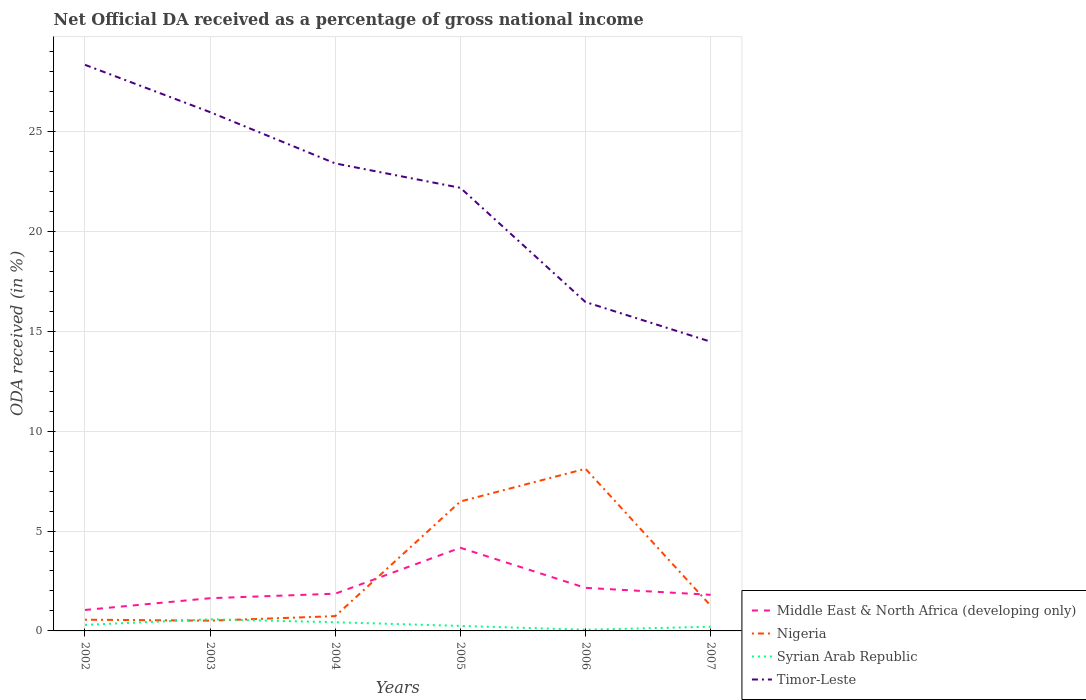Does the line corresponding to Syrian Arab Republic intersect with the line corresponding to Nigeria?
Offer a very short reply. Yes. Is the number of lines equal to the number of legend labels?
Provide a succinct answer. Yes. Across all years, what is the maximum net official DA received in Syrian Arab Republic?
Your answer should be compact. 0.06. What is the total net official DA received in Timor-Leste in the graph?
Your response must be concise. 6.94. What is the difference between the highest and the second highest net official DA received in Nigeria?
Keep it short and to the point. 7.6. Is the net official DA received in Syrian Arab Republic strictly greater than the net official DA received in Middle East & North Africa (developing only) over the years?
Make the answer very short. Yes. How many lines are there?
Offer a terse response. 4. How many years are there in the graph?
Offer a terse response. 6. What is the difference between two consecutive major ticks on the Y-axis?
Offer a very short reply. 5. Are the values on the major ticks of Y-axis written in scientific E-notation?
Provide a succinct answer. No. How many legend labels are there?
Provide a short and direct response. 4. How are the legend labels stacked?
Keep it short and to the point. Vertical. What is the title of the graph?
Your answer should be very brief. Net Official DA received as a percentage of gross national income. Does "Bahrain" appear as one of the legend labels in the graph?
Give a very brief answer. No. What is the label or title of the X-axis?
Provide a short and direct response. Years. What is the label or title of the Y-axis?
Give a very brief answer. ODA received (in %). What is the ODA received (in %) in Middle East & North Africa (developing only) in 2002?
Provide a succinct answer. 1.05. What is the ODA received (in %) of Nigeria in 2002?
Provide a succinct answer. 0.56. What is the ODA received (in %) of Syrian Arab Republic in 2002?
Keep it short and to the point. 0.3. What is the ODA received (in %) of Timor-Leste in 2002?
Provide a short and direct response. 28.34. What is the ODA received (in %) of Middle East & North Africa (developing only) in 2003?
Your answer should be compact. 1.64. What is the ODA received (in %) of Nigeria in 2003?
Keep it short and to the point. 0.51. What is the ODA received (in %) of Syrian Arab Republic in 2003?
Offer a very short reply. 0.58. What is the ODA received (in %) of Timor-Leste in 2003?
Ensure brevity in your answer.  25.97. What is the ODA received (in %) of Middle East & North Africa (developing only) in 2004?
Your response must be concise. 1.86. What is the ODA received (in %) of Nigeria in 2004?
Your answer should be compact. 0.74. What is the ODA received (in %) in Syrian Arab Republic in 2004?
Give a very brief answer. 0.43. What is the ODA received (in %) in Timor-Leste in 2004?
Keep it short and to the point. 23.4. What is the ODA received (in %) in Middle East & North Africa (developing only) in 2005?
Your answer should be compact. 4.16. What is the ODA received (in %) of Nigeria in 2005?
Make the answer very short. 6.48. What is the ODA received (in %) in Syrian Arab Republic in 2005?
Your answer should be very brief. 0.25. What is the ODA received (in %) in Timor-Leste in 2005?
Offer a very short reply. 22.18. What is the ODA received (in %) of Middle East & North Africa (developing only) in 2006?
Offer a terse response. 2.16. What is the ODA received (in %) of Nigeria in 2006?
Your answer should be compact. 8.12. What is the ODA received (in %) of Syrian Arab Republic in 2006?
Offer a very short reply. 0.06. What is the ODA received (in %) of Timor-Leste in 2006?
Make the answer very short. 16.46. What is the ODA received (in %) in Middle East & North Africa (developing only) in 2007?
Your answer should be very brief. 1.81. What is the ODA received (in %) in Nigeria in 2007?
Give a very brief answer. 1.27. What is the ODA received (in %) of Syrian Arab Republic in 2007?
Offer a very short reply. 0.21. What is the ODA received (in %) of Timor-Leste in 2007?
Provide a short and direct response. 14.48. Across all years, what is the maximum ODA received (in %) of Middle East & North Africa (developing only)?
Your answer should be compact. 4.16. Across all years, what is the maximum ODA received (in %) in Nigeria?
Provide a succinct answer. 8.12. Across all years, what is the maximum ODA received (in %) of Syrian Arab Republic?
Keep it short and to the point. 0.58. Across all years, what is the maximum ODA received (in %) of Timor-Leste?
Your answer should be very brief. 28.34. Across all years, what is the minimum ODA received (in %) in Middle East & North Africa (developing only)?
Keep it short and to the point. 1.05. Across all years, what is the minimum ODA received (in %) in Nigeria?
Provide a succinct answer. 0.51. Across all years, what is the minimum ODA received (in %) of Syrian Arab Republic?
Offer a very short reply. 0.06. Across all years, what is the minimum ODA received (in %) in Timor-Leste?
Provide a succinct answer. 14.48. What is the total ODA received (in %) in Middle East & North Africa (developing only) in the graph?
Provide a succinct answer. 12.68. What is the total ODA received (in %) of Nigeria in the graph?
Keep it short and to the point. 17.68. What is the total ODA received (in %) in Syrian Arab Republic in the graph?
Ensure brevity in your answer.  1.84. What is the total ODA received (in %) of Timor-Leste in the graph?
Provide a short and direct response. 130.83. What is the difference between the ODA received (in %) of Middle East & North Africa (developing only) in 2002 and that in 2003?
Offer a very short reply. -0.59. What is the difference between the ODA received (in %) of Nigeria in 2002 and that in 2003?
Offer a terse response. 0.05. What is the difference between the ODA received (in %) of Syrian Arab Republic in 2002 and that in 2003?
Keep it short and to the point. -0.28. What is the difference between the ODA received (in %) of Timor-Leste in 2002 and that in 2003?
Your response must be concise. 2.37. What is the difference between the ODA received (in %) in Middle East & North Africa (developing only) in 2002 and that in 2004?
Offer a very short reply. -0.81. What is the difference between the ODA received (in %) in Nigeria in 2002 and that in 2004?
Your answer should be compact. -0.18. What is the difference between the ODA received (in %) in Syrian Arab Republic in 2002 and that in 2004?
Your response must be concise. -0.13. What is the difference between the ODA received (in %) of Timor-Leste in 2002 and that in 2004?
Give a very brief answer. 4.94. What is the difference between the ODA received (in %) of Middle East & North Africa (developing only) in 2002 and that in 2005?
Your answer should be very brief. -3.11. What is the difference between the ODA received (in %) in Nigeria in 2002 and that in 2005?
Offer a very short reply. -5.92. What is the difference between the ODA received (in %) in Syrian Arab Republic in 2002 and that in 2005?
Your response must be concise. 0.05. What is the difference between the ODA received (in %) of Timor-Leste in 2002 and that in 2005?
Provide a short and direct response. 6.16. What is the difference between the ODA received (in %) in Middle East & North Africa (developing only) in 2002 and that in 2006?
Offer a very short reply. -1.11. What is the difference between the ODA received (in %) of Nigeria in 2002 and that in 2006?
Keep it short and to the point. -7.56. What is the difference between the ODA received (in %) of Syrian Arab Republic in 2002 and that in 2006?
Offer a terse response. 0.24. What is the difference between the ODA received (in %) of Timor-Leste in 2002 and that in 2006?
Ensure brevity in your answer.  11.88. What is the difference between the ODA received (in %) of Middle East & North Africa (developing only) in 2002 and that in 2007?
Your answer should be very brief. -0.76. What is the difference between the ODA received (in %) of Nigeria in 2002 and that in 2007?
Offer a terse response. -0.7. What is the difference between the ODA received (in %) in Syrian Arab Republic in 2002 and that in 2007?
Offer a very short reply. 0.09. What is the difference between the ODA received (in %) in Timor-Leste in 2002 and that in 2007?
Keep it short and to the point. 13.86. What is the difference between the ODA received (in %) in Middle East & North Africa (developing only) in 2003 and that in 2004?
Your answer should be compact. -0.23. What is the difference between the ODA received (in %) in Nigeria in 2003 and that in 2004?
Offer a very short reply. -0.23. What is the difference between the ODA received (in %) in Syrian Arab Republic in 2003 and that in 2004?
Offer a terse response. 0.15. What is the difference between the ODA received (in %) of Timor-Leste in 2003 and that in 2004?
Your answer should be very brief. 2.57. What is the difference between the ODA received (in %) in Middle East & North Africa (developing only) in 2003 and that in 2005?
Make the answer very short. -2.52. What is the difference between the ODA received (in %) in Nigeria in 2003 and that in 2005?
Your answer should be very brief. -5.97. What is the difference between the ODA received (in %) of Syrian Arab Republic in 2003 and that in 2005?
Provide a short and direct response. 0.33. What is the difference between the ODA received (in %) of Timor-Leste in 2003 and that in 2005?
Your answer should be compact. 3.79. What is the difference between the ODA received (in %) of Middle East & North Africa (developing only) in 2003 and that in 2006?
Keep it short and to the point. -0.52. What is the difference between the ODA received (in %) of Nigeria in 2003 and that in 2006?
Make the answer very short. -7.6. What is the difference between the ODA received (in %) in Syrian Arab Republic in 2003 and that in 2006?
Provide a succinct answer. 0.52. What is the difference between the ODA received (in %) of Timor-Leste in 2003 and that in 2006?
Offer a terse response. 9.51. What is the difference between the ODA received (in %) of Middle East & North Africa (developing only) in 2003 and that in 2007?
Give a very brief answer. -0.17. What is the difference between the ODA received (in %) in Nigeria in 2003 and that in 2007?
Provide a short and direct response. -0.75. What is the difference between the ODA received (in %) in Syrian Arab Republic in 2003 and that in 2007?
Your answer should be very brief. 0.37. What is the difference between the ODA received (in %) of Timor-Leste in 2003 and that in 2007?
Provide a succinct answer. 11.49. What is the difference between the ODA received (in %) in Middle East & North Africa (developing only) in 2004 and that in 2005?
Your response must be concise. -2.3. What is the difference between the ODA received (in %) in Nigeria in 2004 and that in 2005?
Give a very brief answer. -5.74. What is the difference between the ODA received (in %) in Syrian Arab Republic in 2004 and that in 2005?
Ensure brevity in your answer.  0.18. What is the difference between the ODA received (in %) of Timor-Leste in 2004 and that in 2005?
Your answer should be very brief. 1.22. What is the difference between the ODA received (in %) in Middle East & North Africa (developing only) in 2004 and that in 2006?
Ensure brevity in your answer.  -0.29. What is the difference between the ODA received (in %) of Nigeria in 2004 and that in 2006?
Ensure brevity in your answer.  -7.38. What is the difference between the ODA received (in %) of Syrian Arab Republic in 2004 and that in 2006?
Give a very brief answer. 0.37. What is the difference between the ODA received (in %) of Timor-Leste in 2004 and that in 2006?
Give a very brief answer. 6.94. What is the difference between the ODA received (in %) of Middle East & North Africa (developing only) in 2004 and that in 2007?
Provide a short and direct response. 0.06. What is the difference between the ODA received (in %) of Nigeria in 2004 and that in 2007?
Provide a short and direct response. -0.53. What is the difference between the ODA received (in %) of Syrian Arab Republic in 2004 and that in 2007?
Make the answer very short. 0.22. What is the difference between the ODA received (in %) in Timor-Leste in 2004 and that in 2007?
Give a very brief answer. 8.92. What is the difference between the ODA received (in %) of Middle East & North Africa (developing only) in 2005 and that in 2006?
Give a very brief answer. 2.01. What is the difference between the ODA received (in %) in Nigeria in 2005 and that in 2006?
Make the answer very short. -1.64. What is the difference between the ODA received (in %) of Syrian Arab Republic in 2005 and that in 2006?
Offer a very short reply. 0.19. What is the difference between the ODA received (in %) of Timor-Leste in 2005 and that in 2006?
Offer a terse response. 5.72. What is the difference between the ODA received (in %) of Middle East & North Africa (developing only) in 2005 and that in 2007?
Give a very brief answer. 2.35. What is the difference between the ODA received (in %) in Nigeria in 2005 and that in 2007?
Make the answer very short. 5.22. What is the difference between the ODA received (in %) in Syrian Arab Republic in 2005 and that in 2007?
Offer a very short reply. 0.04. What is the difference between the ODA received (in %) of Timor-Leste in 2005 and that in 2007?
Your answer should be very brief. 7.7. What is the difference between the ODA received (in %) in Middle East & North Africa (developing only) in 2006 and that in 2007?
Keep it short and to the point. 0.35. What is the difference between the ODA received (in %) of Nigeria in 2006 and that in 2007?
Your answer should be compact. 6.85. What is the difference between the ODA received (in %) of Syrian Arab Republic in 2006 and that in 2007?
Provide a short and direct response. -0.15. What is the difference between the ODA received (in %) of Timor-Leste in 2006 and that in 2007?
Offer a terse response. 1.98. What is the difference between the ODA received (in %) of Middle East & North Africa (developing only) in 2002 and the ODA received (in %) of Nigeria in 2003?
Make the answer very short. 0.54. What is the difference between the ODA received (in %) of Middle East & North Africa (developing only) in 2002 and the ODA received (in %) of Syrian Arab Republic in 2003?
Offer a very short reply. 0.47. What is the difference between the ODA received (in %) of Middle East & North Africa (developing only) in 2002 and the ODA received (in %) of Timor-Leste in 2003?
Offer a very short reply. -24.92. What is the difference between the ODA received (in %) of Nigeria in 2002 and the ODA received (in %) of Syrian Arab Republic in 2003?
Your answer should be very brief. -0.02. What is the difference between the ODA received (in %) in Nigeria in 2002 and the ODA received (in %) in Timor-Leste in 2003?
Provide a short and direct response. -25.41. What is the difference between the ODA received (in %) in Syrian Arab Republic in 2002 and the ODA received (in %) in Timor-Leste in 2003?
Ensure brevity in your answer.  -25.66. What is the difference between the ODA received (in %) of Middle East & North Africa (developing only) in 2002 and the ODA received (in %) of Nigeria in 2004?
Give a very brief answer. 0.31. What is the difference between the ODA received (in %) of Middle East & North Africa (developing only) in 2002 and the ODA received (in %) of Syrian Arab Republic in 2004?
Your answer should be very brief. 0.61. What is the difference between the ODA received (in %) of Middle East & North Africa (developing only) in 2002 and the ODA received (in %) of Timor-Leste in 2004?
Provide a short and direct response. -22.35. What is the difference between the ODA received (in %) in Nigeria in 2002 and the ODA received (in %) in Syrian Arab Republic in 2004?
Ensure brevity in your answer.  0.13. What is the difference between the ODA received (in %) in Nigeria in 2002 and the ODA received (in %) in Timor-Leste in 2004?
Make the answer very short. -22.84. What is the difference between the ODA received (in %) of Syrian Arab Republic in 2002 and the ODA received (in %) of Timor-Leste in 2004?
Provide a succinct answer. -23.1. What is the difference between the ODA received (in %) in Middle East & North Africa (developing only) in 2002 and the ODA received (in %) in Nigeria in 2005?
Give a very brief answer. -5.43. What is the difference between the ODA received (in %) in Middle East & North Africa (developing only) in 2002 and the ODA received (in %) in Syrian Arab Republic in 2005?
Keep it short and to the point. 0.8. What is the difference between the ODA received (in %) of Middle East & North Africa (developing only) in 2002 and the ODA received (in %) of Timor-Leste in 2005?
Your answer should be compact. -21.13. What is the difference between the ODA received (in %) in Nigeria in 2002 and the ODA received (in %) in Syrian Arab Republic in 2005?
Offer a terse response. 0.31. What is the difference between the ODA received (in %) in Nigeria in 2002 and the ODA received (in %) in Timor-Leste in 2005?
Give a very brief answer. -21.62. What is the difference between the ODA received (in %) in Syrian Arab Republic in 2002 and the ODA received (in %) in Timor-Leste in 2005?
Offer a very short reply. -21.88. What is the difference between the ODA received (in %) of Middle East & North Africa (developing only) in 2002 and the ODA received (in %) of Nigeria in 2006?
Your response must be concise. -7.07. What is the difference between the ODA received (in %) in Middle East & North Africa (developing only) in 2002 and the ODA received (in %) in Syrian Arab Republic in 2006?
Make the answer very short. 0.99. What is the difference between the ODA received (in %) of Middle East & North Africa (developing only) in 2002 and the ODA received (in %) of Timor-Leste in 2006?
Make the answer very short. -15.41. What is the difference between the ODA received (in %) in Nigeria in 2002 and the ODA received (in %) in Syrian Arab Republic in 2006?
Your answer should be very brief. 0.5. What is the difference between the ODA received (in %) of Nigeria in 2002 and the ODA received (in %) of Timor-Leste in 2006?
Give a very brief answer. -15.9. What is the difference between the ODA received (in %) of Syrian Arab Republic in 2002 and the ODA received (in %) of Timor-Leste in 2006?
Provide a short and direct response. -16.16. What is the difference between the ODA received (in %) of Middle East & North Africa (developing only) in 2002 and the ODA received (in %) of Nigeria in 2007?
Make the answer very short. -0.22. What is the difference between the ODA received (in %) in Middle East & North Africa (developing only) in 2002 and the ODA received (in %) in Syrian Arab Republic in 2007?
Give a very brief answer. 0.84. What is the difference between the ODA received (in %) in Middle East & North Africa (developing only) in 2002 and the ODA received (in %) in Timor-Leste in 2007?
Your response must be concise. -13.43. What is the difference between the ODA received (in %) in Nigeria in 2002 and the ODA received (in %) in Syrian Arab Republic in 2007?
Your answer should be very brief. 0.35. What is the difference between the ODA received (in %) of Nigeria in 2002 and the ODA received (in %) of Timor-Leste in 2007?
Keep it short and to the point. -13.92. What is the difference between the ODA received (in %) of Syrian Arab Republic in 2002 and the ODA received (in %) of Timor-Leste in 2007?
Your response must be concise. -14.17. What is the difference between the ODA received (in %) in Middle East & North Africa (developing only) in 2003 and the ODA received (in %) in Nigeria in 2004?
Your answer should be compact. 0.9. What is the difference between the ODA received (in %) in Middle East & North Africa (developing only) in 2003 and the ODA received (in %) in Syrian Arab Republic in 2004?
Provide a short and direct response. 1.2. What is the difference between the ODA received (in %) of Middle East & North Africa (developing only) in 2003 and the ODA received (in %) of Timor-Leste in 2004?
Ensure brevity in your answer.  -21.76. What is the difference between the ODA received (in %) of Nigeria in 2003 and the ODA received (in %) of Syrian Arab Republic in 2004?
Your response must be concise. 0.08. What is the difference between the ODA received (in %) of Nigeria in 2003 and the ODA received (in %) of Timor-Leste in 2004?
Ensure brevity in your answer.  -22.89. What is the difference between the ODA received (in %) of Syrian Arab Republic in 2003 and the ODA received (in %) of Timor-Leste in 2004?
Provide a succinct answer. -22.82. What is the difference between the ODA received (in %) in Middle East & North Africa (developing only) in 2003 and the ODA received (in %) in Nigeria in 2005?
Ensure brevity in your answer.  -4.84. What is the difference between the ODA received (in %) of Middle East & North Africa (developing only) in 2003 and the ODA received (in %) of Syrian Arab Republic in 2005?
Your response must be concise. 1.39. What is the difference between the ODA received (in %) in Middle East & North Africa (developing only) in 2003 and the ODA received (in %) in Timor-Leste in 2005?
Your response must be concise. -20.54. What is the difference between the ODA received (in %) of Nigeria in 2003 and the ODA received (in %) of Syrian Arab Republic in 2005?
Give a very brief answer. 0.26. What is the difference between the ODA received (in %) of Nigeria in 2003 and the ODA received (in %) of Timor-Leste in 2005?
Give a very brief answer. -21.67. What is the difference between the ODA received (in %) in Syrian Arab Republic in 2003 and the ODA received (in %) in Timor-Leste in 2005?
Offer a terse response. -21.6. What is the difference between the ODA received (in %) in Middle East & North Africa (developing only) in 2003 and the ODA received (in %) in Nigeria in 2006?
Keep it short and to the point. -6.48. What is the difference between the ODA received (in %) in Middle East & North Africa (developing only) in 2003 and the ODA received (in %) in Syrian Arab Republic in 2006?
Your answer should be compact. 1.58. What is the difference between the ODA received (in %) in Middle East & North Africa (developing only) in 2003 and the ODA received (in %) in Timor-Leste in 2006?
Keep it short and to the point. -14.82. What is the difference between the ODA received (in %) of Nigeria in 2003 and the ODA received (in %) of Syrian Arab Republic in 2006?
Make the answer very short. 0.45. What is the difference between the ODA received (in %) of Nigeria in 2003 and the ODA received (in %) of Timor-Leste in 2006?
Make the answer very short. -15.95. What is the difference between the ODA received (in %) in Syrian Arab Republic in 2003 and the ODA received (in %) in Timor-Leste in 2006?
Make the answer very short. -15.88. What is the difference between the ODA received (in %) in Middle East & North Africa (developing only) in 2003 and the ODA received (in %) in Nigeria in 2007?
Offer a very short reply. 0.37. What is the difference between the ODA received (in %) of Middle East & North Africa (developing only) in 2003 and the ODA received (in %) of Syrian Arab Republic in 2007?
Keep it short and to the point. 1.43. What is the difference between the ODA received (in %) in Middle East & North Africa (developing only) in 2003 and the ODA received (in %) in Timor-Leste in 2007?
Your response must be concise. -12.84. What is the difference between the ODA received (in %) of Nigeria in 2003 and the ODA received (in %) of Syrian Arab Republic in 2007?
Ensure brevity in your answer.  0.3. What is the difference between the ODA received (in %) of Nigeria in 2003 and the ODA received (in %) of Timor-Leste in 2007?
Keep it short and to the point. -13.96. What is the difference between the ODA received (in %) of Syrian Arab Republic in 2003 and the ODA received (in %) of Timor-Leste in 2007?
Offer a terse response. -13.9. What is the difference between the ODA received (in %) in Middle East & North Africa (developing only) in 2004 and the ODA received (in %) in Nigeria in 2005?
Give a very brief answer. -4.62. What is the difference between the ODA received (in %) of Middle East & North Africa (developing only) in 2004 and the ODA received (in %) of Syrian Arab Republic in 2005?
Offer a terse response. 1.61. What is the difference between the ODA received (in %) of Middle East & North Africa (developing only) in 2004 and the ODA received (in %) of Timor-Leste in 2005?
Give a very brief answer. -20.32. What is the difference between the ODA received (in %) of Nigeria in 2004 and the ODA received (in %) of Syrian Arab Republic in 2005?
Ensure brevity in your answer.  0.49. What is the difference between the ODA received (in %) of Nigeria in 2004 and the ODA received (in %) of Timor-Leste in 2005?
Your answer should be compact. -21.44. What is the difference between the ODA received (in %) of Syrian Arab Republic in 2004 and the ODA received (in %) of Timor-Leste in 2005?
Provide a succinct answer. -21.75. What is the difference between the ODA received (in %) of Middle East & North Africa (developing only) in 2004 and the ODA received (in %) of Nigeria in 2006?
Your answer should be very brief. -6.25. What is the difference between the ODA received (in %) in Middle East & North Africa (developing only) in 2004 and the ODA received (in %) in Syrian Arab Republic in 2006?
Give a very brief answer. 1.8. What is the difference between the ODA received (in %) of Middle East & North Africa (developing only) in 2004 and the ODA received (in %) of Timor-Leste in 2006?
Keep it short and to the point. -14.6. What is the difference between the ODA received (in %) of Nigeria in 2004 and the ODA received (in %) of Syrian Arab Republic in 2006?
Make the answer very short. 0.68. What is the difference between the ODA received (in %) of Nigeria in 2004 and the ODA received (in %) of Timor-Leste in 2006?
Provide a short and direct response. -15.72. What is the difference between the ODA received (in %) of Syrian Arab Republic in 2004 and the ODA received (in %) of Timor-Leste in 2006?
Ensure brevity in your answer.  -16.03. What is the difference between the ODA received (in %) of Middle East & North Africa (developing only) in 2004 and the ODA received (in %) of Nigeria in 2007?
Offer a terse response. 0.6. What is the difference between the ODA received (in %) in Middle East & North Africa (developing only) in 2004 and the ODA received (in %) in Syrian Arab Republic in 2007?
Offer a terse response. 1.65. What is the difference between the ODA received (in %) in Middle East & North Africa (developing only) in 2004 and the ODA received (in %) in Timor-Leste in 2007?
Provide a succinct answer. -12.61. What is the difference between the ODA received (in %) in Nigeria in 2004 and the ODA received (in %) in Syrian Arab Republic in 2007?
Provide a short and direct response. 0.53. What is the difference between the ODA received (in %) in Nigeria in 2004 and the ODA received (in %) in Timor-Leste in 2007?
Your answer should be very brief. -13.74. What is the difference between the ODA received (in %) in Syrian Arab Republic in 2004 and the ODA received (in %) in Timor-Leste in 2007?
Provide a succinct answer. -14.04. What is the difference between the ODA received (in %) in Middle East & North Africa (developing only) in 2005 and the ODA received (in %) in Nigeria in 2006?
Make the answer very short. -3.95. What is the difference between the ODA received (in %) in Middle East & North Africa (developing only) in 2005 and the ODA received (in %) in Syrian Arab Republic in 2006?
Keep it short and to the point. 4.1. What is the difference between the ODA received (in %) of Middle East & North Africa (developing only) in 2005 and the ODA received (in %) of Timor-Leste in 2006?
Give a very brief answer. -12.3. What is the difference between the ODA received (in %) in Nigeria in 2005 and the ODA received (in %) in Syrian Arab Republic in 2006?
Your response must be concise. 6.42. What is the difference between the ODA received (in %) in Nigeria in 2005 and the ODA received (in %) in Timor-Leste in 2006?
Offer a very short reply. -9.98. What is the difference between the ODA received (in %) in Syrian Arab Republic in 2005 and the ODA received (in %) in Timor-Leste in 2006?
Provide a succinct answer. -16.21. What is the difference between the ODA received (in %) in Middle East & North Africa (developing only) in 2005 and the ODA received (in %) in Nigeria in 2007?
Provide a succinct answer. 2.9. What is the difference between the ODA received (in %) in Middle East & North Africa (developing only) in 2005 and the ODA received (in %) in Syrian Arab Republic in 2007?
Give a very brief answer. 3.95. What is the difference between the ODA received (in %) of Middle East & North Africa (developing only) in 2005 and the ODA received (in %) of Timor-Leste in 2007?
Provide a short and direct response. -10.32. What is the difference between the ODA received (in %) in Nigeria in 2005 and the ODA received (in %) in Syrian Arab Republic in 2007?
Your answer should be very brief. 6.27. What is the difference between the ODA received (in %) of Nigeria in 2005 and the ODA received (in %) of Timor-Leste in 2007?
Provide a succinct answer. -8. What is the difference between the ODA received (in %) of Syrian Arab Republic in 2005 and the ODA received (in %) of Timor-Leste in 2007?
Offer a very short reply. -14.23. What is the difference between the ODA received (in %) of Middle East & North Africa (developing only) in 2006 and the ODA received (in %) of Nigeria in 2007?
Provide a short and direct response. 0.89. What is the difference between the ODA received (in %) of Middle East & North Africa (developing only) in 2006 and the ODA received (in %) of Syrian Arab Republic in 2007?
Your answer should be very brief. 1.95. What is the difference between the ODA received (in %) in Middle East & North Africa (developing only) in 2006 and the ODA received (in %) in Timor-Leste in 2007?
Provide a short and direct response. -12.32. What is the difference between the ODA received (in %) in Nigeria in 2006 and the ODA received (in %) in Syrian Arab Republic in 2007?
Provide a succinct answer. 7.91. What is the difference between the ODA received (in %) of Nigeria in 2006 and the ODA received (in %) of Timor-Leste in 2007?
Your answer should be compact. -6.36. What is the difference between the ODA received (in %) of Syrian Arab Republic in 2006 and the ODA received (in %) of Timor-Leste in 2007?
Your answer should be compact. -14.42. What is the average ODA received (in %) in Middle East & North Africa (developing only) per year?
Offer a very short reply. 2.11. What is the average ODA received (in %) in Nigeria per year?
Your answer should be very brief. 2.95. What is the average ODA received (in %) in Syrian Arab Republic per year?
Your answer should be compact. 0.31. What is the average ODA received (in %) in Timor-Leste per year?
Provide a succinct answer. 21.8. In the year 2002, what is the difference between the ODA received (in %) in Middle East & North Africa (developing only) and ODA received (in %) in Nigeria?
Offer a terse response. 0.49. In the year 2002, what is the difference between the ODA received (in %) of Middle East & North Africa (developing only) and ODA received (in %) of Syrian Arab Republic?
Give a very brief answer. 0.74. In the year 2002, what is the difference between the ODA received (in %) of Middle East & North Africa (developing only) and ODA received (in %) of Timor-Leste?
Ensure brevity in your answer.  -27.29. In the year 2002, what is the difference between the ODA received (in %) of Nigeria and ODA received (in %) of Syrian Arab Republic?
Your response must be concise. 0.26. In the year 2002, what is the difference between the ODA received (in %) in Nigeria and ODA received (in %) in Timor-Leste?
Provide a short and direct response. -27.78. In the year 2002, what is the difference between the ODA received (in %) of Syrian Arab Republic and ODA received (in %) of Timor-Leste?
Your answer should be compact. -28.03. In the year 2003, what is the difference between the ODA received (in %) of Middle East & North Africa (developing only) and ODA received (in %) of Nigeria?
Keep it short and to the point. 1.12. In the year 2003, what is the difference between the ODA received (in %) of Middle East & North Africa (developing only) and ODA received (in %) of Syrian Arab Republic?
Your response must be concise. 1.06. In the year 2003, what is the difference between the ODA received (in %) in Middle East & North Africa (developing only) and ODA received (in %) in Timor-Leste?
Keep it short and to the point. -24.33. In the year 2003, what is the difference between the ODA received (in %) in Nigeria and ODA received (in %) in Syrian Arab Republic?
Your answer should be compact. -0.07. In the year 2003, what is the difference between the ODA received (in %) of Nigeria and ODA received (in %) of Timor-Leste?
Your answer should be very brief. -25.46. In the year 2003, what is the difference between the ODA received (in %) of Syrian Arab Republic and ODA received (in %) of Timor-Leste?
Make the answer very short. -25.39. In the year 2004, what is the difference between the ODA received (in %) of Middle East & North Africa (developing only) and ODA received (in %) of Nigeria?
Make the answer very short. 1.12. In the year 2004, what is the difference between the ODA received (in %) of Middle East & North Africa (developing only) and ODA received (in %) of Syrian Arab Republic?
Ensure brevity in your answer.  1.43. In the year 2004, what is the difference between the ODA received (in %) in Middle East & North Africa (developing only) and ODA received (in %) in Timor-Leste?
Keep it short and to the point. -21.54. In the year 2004, what is the difference between the ODA received (in %) of Nigeria and ODA received (in %) of Syrian Arab Republic?
Your response must be concise. 0.31. In the year 2004, what is the difference between the ODA received (in %) in Nigeria and ODA received (in %) in Timor-Leste?
Provide a succinct answer. -22.66. In the year 2004, what is the difference between the ODA received (in %) in Syrian Arab Republic and ODA received (in %) in Timor-Leste?
Your answer should be very brief. -22.97. In the year 2005, what is the difference between the ODA received (in %) of Middle East & North Africa (developing only) and ODA received (in %) of Nigeria?
Your answer should be compact. -2.32. In the year 2005, what is the difference between the ODA received (in %) in Middle East & North Africa (developing only) and ODA received (in %) in Syrian Arab Republic?
Ensure brevity in your answer.  3.91. In the year 2005, what is the difference between the ODA received (in %) of Middle East & North Africa (developing only) and ODA received (in %) of Timor-Leste?
Provide a short and direct response. -18.02. In the year 2005, what is the difference between the ODA received (in %) in Nigeria and ODA received (in %) in Syrian Arab Republic?
Your answer should be very brief. 6.23. In the year 2005, what is the difference between the ODA received (in %) of Nigeria and ODA received (in %) of Timor-Leste?
Make the answer very short. -15.7. In the year 2005, what is the difference between the ODA received (in %) of Syrian Arab Republic and ODA received (in %) of Timor-Leste?
Offer a terse response. -21.93. In the year 2006, what is the difference between the ODA received (in %) of Middle East & North Africa (developing only) and ODA received (in %) of Nigeria?
Provide a succinct answer. -5.96. In the year 2006, what is the difference between the ODA received (in %) of Middle East & North Africa (developing only) and ODA received (in %) of Syrian Arab Republic?
Your answer should be very brief. 2.1. In the year 2006, what is the difference between the ODA received (in %) of Middle East & North Africa (developing only) and ODA received (in %) of Timor-Leste?
Give a very brief answer. -14.31. In the year 2006, what is the difference between the ODA received (in %) of Nigeria and ODA received (in %) of Syrian Arab Republic?
Offer a terse response. 8.06. In the year 2006, what is the difference between the ODA received (in %) in Nigeria and ODA received (in %) in Timor-Leste?
Provide a short and direct response. -8.35. In the year 2006, what is the difference between the ODA received (in %) of Syrian Arab Republic and ODA received (in %) of Timor-Leste?
Your answer should be compact. -16.4. In the year 2007, what is the difference between the ODA received (in %) in Middle East & North Africa (developing only) and ODA received (in %) in Nigeria?
Keep it short and to the point. 0.54. In the year 2007, what is the difference between the ODA received (in %) of Middle East & North Africa (developing only) and ODA received (in %) of Syrian Arab Republic?
Provide a short and direct response. 1.6. In the year 2007, what is the difference between the ODA received (in %) of Middle East & North Africa (developing only) and ODA received (in %) of Timor-Leste?
Your answer should be compact. -12.67. In the year 2007, what is the difference between the ODA received (in %) in Nigeria and ODA received (in %) in Syrian Arab Republic?
Your answer should be compact. 1.05. In the year 2007, what is the difference between the ODA received (in %) of Nigeria and ODA received (in %) of Timor-Leste?
Offer a terse response. -13.21. In the year 2007, what is the difference between the ODA received (in %) of Syrian Arab Republic and ODA received (in %) of Timor-Leste?
Your answer should be compact. -14.27. What is the ratio of the ODA received (in %) of Middle East & North Africa (developing only) in 2002 to that in 2003?
Provide a succinct answer. 0.64. What is the ratio of the ODA received (in %) of Nigeria in 2002 to that in 2003?
Provide a short and direct response. 1.09. What is the ratio of the ODA received (in %) of Syrian Arab Republic in 2002 to that in 2003?
Offer a terse response. 0.52. What is the ratio of the ODA received (in %) of Timor-Leste in 2002 to that in 2003?
Ensure brevity in your answer.  1.09. What is the ratio of the ODA received (in %) of Middle East & North Africa (developing only) in 2002 to that in 2004?
Provide a succinct answer. 0.56. What is the ratio of the ODA received (in %) in Nigeria in 2002 to that in 2004?
Your answer should be compact. 0.76. What is the ratio of the ODA received (in %) in Syrian Arab Republic in 2002 to that in 2004?
Provide a succinct answer. 0.7. What is the ratio of the ODA received (in %) of Timor-Leste in 2002 to that in 2004?
Offer a terse response. 1.21. What is the ratio of the ODA received (in %) in Middle East & North Africa (developing only) in 2002 to that in 2005?
Provide a short and direct response. 0.25. What is the ratio of the ODA received (in %) of Nigeria in 2002 to that in 2005?
Offer a very short reply. 0.09. What is the ratio of the ODA received (in %) of Syrian Arab Republic in 2002 to that in 2005?
Your answer should be compact. 1.21. What is the ratio of the ODA received (in %) in Timor-Leste in 2002 to that in 2005?
Give a very brief answer. 1.28. What is the ratio of the ODA received (in %) in Middle East & North Africa (developing only) in 2002 to that in 2006?
Provide a short and direct response. 0.49. What is the ratio of the ODA received (in %) of Nigeria in 2002 to that in 2006?
Ensure brevity in your answer.  0.07. What is the ratio of the ODA received (in %) in Syrian Arab Republic in 2002 to that in 2006?
Your answer should be very brief. 5.13. What is the ratio of the ODA received (in %) of Timor-Leste in 2002 to that in 2006?
Your answer should be compact. 1.72. What is the ratio of the ODA received (in %) in Middle East & North Africa (developing only) in 2002 to that in 2007?
Your response must be concise. 0.58. What is the ratio of the ODA received (in %) in Nigeria in 2002 to that in 2007?
Ensure brevity in your answer.  0.44. What is the ratio of the ODA received (in %) in Syrian Arab Republic in 2002 to that in 2007?
Your answer should be compact. 1.44. What is the ratio of the ODA received (in %) of Timor-Leste in 2002 to that in 2007?
Make the answer very short. 1.96. What is the ratio of the ODA received (in %) in Middle East & North Africa (developing only) in 2003 to that in 2004?
Keep it short and to the point. 0.88. What is the ratio of the ODA received (in %) of Nigeria in 2003 to that in 2004?
Make the answer very short. 0.69. What is the ratio of the ODA received (in %) of Syrian Arab Republic in 2003 to that in 2004?
Provide a short and direct response. 1.34. What is the ratio of the ODA received (in %) in Timor-Leste in 2003 to that in 2004?
Your response must be concise. 1.11. What is the ratio of the ODA received (in %) in Middle East & North Africa (developing only) in 2003 to that in 2005?
Offer a terse response. 0.39. What is the ratio of the ODA received (in %) in Nigeria in 2003 to that in 2005?
Your answer should be very brief. 0.08. What is the ratio of the ODA received (in %) of Syrian Arab Republic in 2003 to that in 2005?
Your answer should be compact. 2.32. What is the ratio of the ODA received (in %) in Timor-Leste in 2003 to that in 2005?
Offer a very short reply. 1.17. What is the ratio of the ODA received (in %) of Middle East & North Africa (developing only) in 2003 to that in 2006?
Offer a very short reply. 0.76. What is the ratio of the ODA received (in %) in Nigeria in 2003 to that in 2006?
Offer a terse response. 0.06. What is the ratio of the ODA received (in %) of Syrian Arab Republic in 2003 to that in 2006?
Provide a succinct answer. 9.83. What is the ratio of the ODA received (in %) of Timor-Leste in 2003 to that in 2006?
Offer a terse response. 1.58. What is the ratio of the ODA received (in %) of Middle East & North Africa (developing only) in 2003 to that in 2007?
Offer a very short reply. 0.91. What is the ratio of the ODA received (in %) of Nigeria in 2003 to that in 2007?
Your answer should be very brief. 0.41. What is the ratio of the ODA received (in %) of Syrian Arab Republic in 2003 to that in 2007?
Offer a terse response. 2.77. What is the ratio of the ODA received (in %) in Timor-Leste in 2003 to that in 2007?
Keep it short and to the point. 1.79. What is the ratio of the ODA received (in %) of Middle East & North Africa (developing only) in 2004 to that in 2005?
Provide a succinct answer. 0.45. What is the ratio of the ODA received (in %) of Nigeria in 2004 to that in 2005?
Provide a short and direct response. 0.11. What is the ratio of the ODA received (in %) of Syrian Arab Republic in 2004 to that in 2005?
Provide a short and direct response. 1.73. What is the ratio of the ODA received (in %) in Timor-Leste in 2004 to that in 2005?
Ensure brevity in your answer.  1.06. What is the ratio of the ODA received (in %) in Middle East & North Africa (developing only) in 2004 to that in 2006?
Make the answer very short. 0.86. What is the ratio of the ODA received (in %) of Nigeria in 2004 to that in 2006?
Offer a very short reply. 0.09. What is the ratio of the ODA received (in %) of Syrian Arab Republic in 2004 to that in 2006?
Your response must be concise. 7.33. What is the ratio of the ODA received (in %) in Timor-Leste in 2004 to that in 2006?
Provide a succinct answer. 1.42. What is the ratio of the ODA received (in %) in Middle East & North Africa (developing only) in 2004 to that in 2007?
Provide a succinct answer. 1.03. What is the ratio of the ODA received (in %) of Nigeria in 2004 to that in 2007?
Make the answer very short. 0.58. What is the ratio of the ODA received (in %) in Syrian Arab Republic in 2004 to that in 2007?
Make the answer very short. 2.06. What is the ratio of the ODA received (in %) in Timor-Leste in 2004 to that in 2007?
Offer a very short reply. 1.62. What is the ratio of the ODA received (in %) in Middle East & North Africa (developing only) in 2005 to that in 2006?
Keep it short and to the point. 1.93. What is the ratio of the ODA received (in %) in Nigeria in 2005 to that in 2006?
Provide a short and direct response. 0.8. What is the ratio of the ODA received (in %) in Syrian Arab Republic in 2005 to that in 2006?
Make the answer very short. 4.24. What is the ratio of the ODA received (in %) of Timor-Leste in 2005 to that in 2006?
Give a very brief answer. 1.35. What is the ratio of the ODA received (in %) of Middle East & North Africa (developing only) in 2005 to that in 2007?
Make the answer very short. 2.3. What is the ratio of the ODA received (in %) of Nigeria in 2005 to that in 2007?
Give a very brief answer. 5.12. What is the ratio of the ODA received (in %) of Syrian Arab Republic in 2005 to that in 2007?
Your answer should be very brief. 1.19. What is the ratio of the ODA received (in %) of Timor-Leste in 2005 to that in 2007?
Keep it short and to the point. 1.53. What is the ratio of the ODA received (in %) of Middle East & North Africa (developing only) in 2006 to that in 2007?
Your response must be concise. 1.19. What is the ratio of the ODA received (in %) of Nigeria in 2006 to that in 2007?
Your answer should be compact. 6.42. What is the ratio of the ODA received (in %) of Syrian Arab Republic in 2006 to that in 2007?
Provide a short and direct response. 0.28. What is the ratio of the ODA received (in %) in Timor-Leste in 2006 to that in 2007?
Give a very brief answer. 1.14. What is the difference between the highest and the second highest ODA received (in %) in Middle East & North Africa (developing only)?
Ensure brevity in your answer.  2.01. What is the difference between the highest and the second highest ODA received (in %) of Nigeria?
Your answer should be very brief. 1.64. What is the difference between the highest and the second highest ODA received (in %) of Syrian Arab Republic?
Provide a short and direct response. 0.15. What is the difference between the highest and the second highest ODA received (in %) of Timor-Leste?
Offer a very short reply. 2.37. What is the difference between the highest and the lowest ODA received (in %) in Middle East & North Africa (developing only)?
Provide a succinct answer. 3.11. What is the difference between the highest and the lowest ODA received (in %) of Nigeria?
Your answer should be compact. 7.6. What is the difference between the highest and the lowest ODA received (in %) of Syrian Arab Republic?
Offer a very short reply. 0.52. What is the difference between the highest and the lowest ODA received (in %) in Timor-Leste?
Keep it short and to the point. 13.86. 